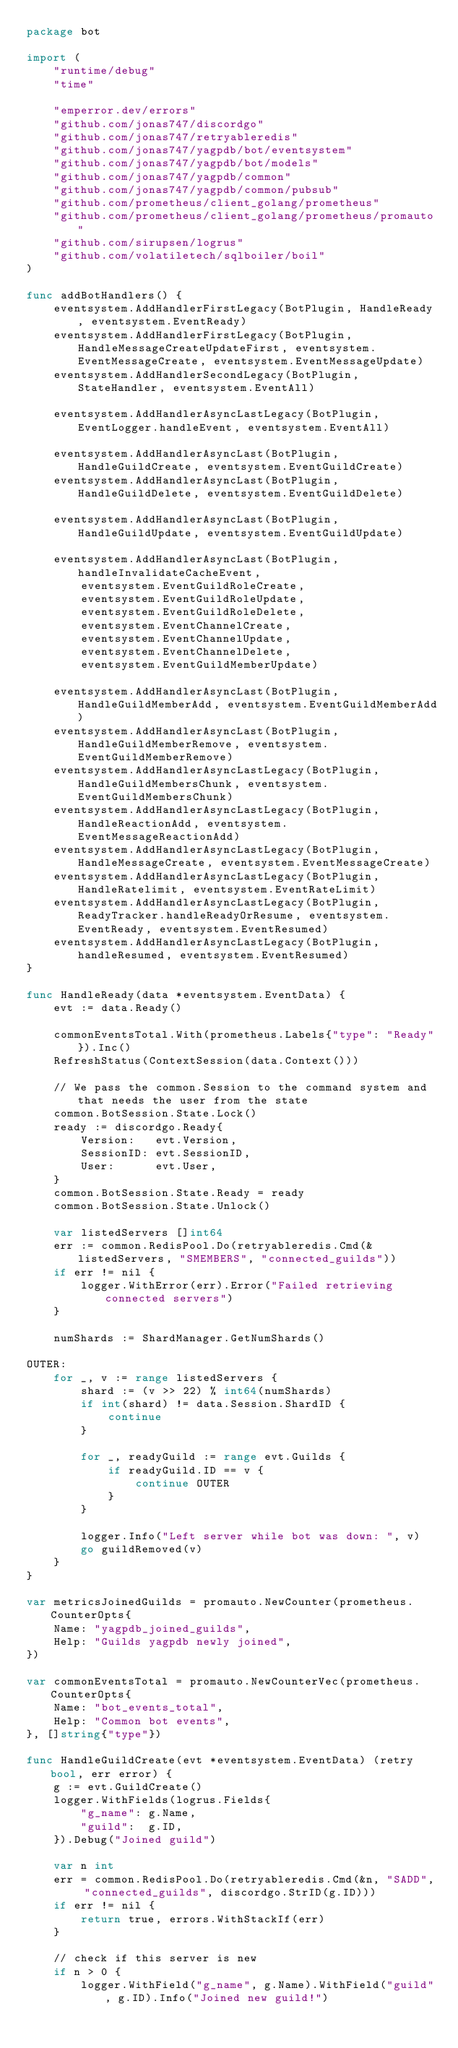Convert code to text. <code><loc_0><loc_0><loc_500><loc_500><_Go_>package bot

import (
	"runtime/debug"
	"time"

	"emperror.dev/errors"
	"github.com/jonas747/discordgo"
	"github.com/jonas747/retryableredis"
	"github.com/jonas747/yagpdb/bot/eventsystem"
	"github.com/jonas747/yagpdb/bot/models"
	"github.com/jonas747/yagpdb/common"
	"github.com/jonas747/yagpdb/common/pubsub"
	"github.com/prometheus/client_golang/prometheus"
	"github.com/prometheus/client_golang/prometheus/promauto"
	"github.com/sirupsen/logrus"
	"github.com/volatiletech/sqlboiler/boil"
)

func addBotHandlers() {
	eventsystem.AddHandlerFirstLegacy(BotPlugin, HandleReady, eventsystem.EventReady)
	eventsystem.AddHandlerFirstLegacy(BotPlugin, HandleMessageCreateUpdateFirst, eventsystem.EventMessageCreate, eventsystem.EventMessageUpdate)
	eventsystem.AddHandlerSecondLegacy(BotPlugin, StateHandler, eventsystem.EventAll)

	eventsystem.AddHandlerAsyncLastLegacy(BotPlugin, EventLogger.handleEvent, eventsystem.EventAll)

	eventsystem.AddHandlerAsyncLast(BotPlugin, HandleGuildCreate, eventsystem.EventGuildCreate)
	eventsystem.AddHandlerAsyncLast(BotPlugin, HandleGuildDelete, eventsystem.EventGuildDelete)

	eventsystem.AddHandlerAsyncLast(BotPlugin, HandleGuildUpdate, eventsystem.EventGuildUpdate)

	eventsystem.AddHandlerAsyncLast(BotPlugin, handleInvalidateCacheEvent,
		eventsystem.EventGuildRoleCreate,
		eventsystem.EventGuildRoleUpdate,
		eventsystem.EventGuildRoleDelete,
		eventsystem.EventChannelCreate,
		eventsystem.EventChannelUpdate,
		eventsystem.EventChannelDelete,
		eventsystem.EventGuildMemberUpdate)

	eventsystem.AddHandlerAsyncLast(BotPlugin, HandleGuildMemberAdd, eventsystem.EventGuildMemberAdd)
	eventsystem.AddHandlerAsyncLast(BotPlugin, HandleGuildMemberRemove, eventsystem.EventGuildMemberRemove)
	eventsystem.AddHandlerAsyncLastLegacy(BotPlugin, HandleGuildMembersChunk, eventsystem.EventGuildMembersChunk)
	eventsystem.AddHandlerAsyncLastLegacy(BotPlugin, HandleReactionAdd, eventsystem.EventMessageReactionAdd)
	eventsystem.AddHandlerAsyncLastLegacy(BotPlugin, HandleMessageCreate, eventsystem.EventMessageCreate)
	eventsystem.AddHandlerAsyncLastLegacy(BotPlugin, HandleRatelimit, eventsystem.EventRateLimit)
	eventsystem.AddHandlerAsyncLastLegacy(BotPlugin, ReadyTracker.handleReadyOrResume, eventsystem.EventReady, eventsystem.EventResumed)
	eventsystem.AddHandlerAsyncLastLegacy(BotPlugin, handleResumed, eventsystem.EventResumed)
}

func HandleReady(data *eventsystem.EventData) {
	evt := data.Ready()

	commonEventsTotal.With(prometheus.Labels{"type": "Ready"}).Inc()
	RefreshStatus(ContextSession(data.Context()))

	// We pass the common.Session to the command system and that needs the user from the state
	common.BotSession.State.Lock()
	ready := discordgo.Ready{
		Version:   evt.Version,
		SessionID: evt.SessionID,
		User:      evt.User,
	}
	common.BotSession.State.Ready = ready
	common.BotSession.State.Unlock()

	var listedServers []int64
	err := common.RedisPool.Do(retryableredis.Cmd(&listedServers, "SMEMBERS", "connected_guilds"))
	if err != nil {
		logger.WithError(err).Error("Failed retrieving connected servers")
	}

	numShards := ShardManager.GetNumShards()

OUTER:
	for _, v := range listedServers {
		shard := (v >> 22) % int64(numShards)
		if int(shard) != data.Session.ShardID {
			continue
		}

		for _, readyGuild := range evt.Guilds {
			if readyGuild.ID == v {
				continue OUTER
			}
		}

		logger.Info("Left server while bot was down: ", v)
		go guildRemoved(v)
	}
}

var metricsJoinedGuilds = promauto.NewCounter(prometheus.CounterOpts{
	Name: "yagpdb_joined_guilds",
	Help: "Guilds yagpdb newly joined",
})

var commonEventsTotal = promauto.NewCounterVec(prometheus.CounterOpts{
	Name: "bot_events_total",
	Help: "Common bot events",
}, []string{"type"})

func HandleGuildCreate(evt *eventsystem.EventData) (retry bool, err error) {
	g := evt.GuildCreate()
	logger.WithFields(logrus.Fields{
		"g_name": g.Name,
		"guild":  g.ID,
	}).Debug("Joined guild")

	var n int
	err = common.RedisPool.Do(retryableredis.Cmd(&n, "SADD", "connected_guilds", discordgo.StrID(g.ID)))
	if err != nil {
		return true, errors.WithStackIf(err)
	}

	// check if this server is new
	if n > 0 {
		logger.WithField("g_name", g.Name).WithField("guild", g.ID).Info("Joined new guild!")</code> 